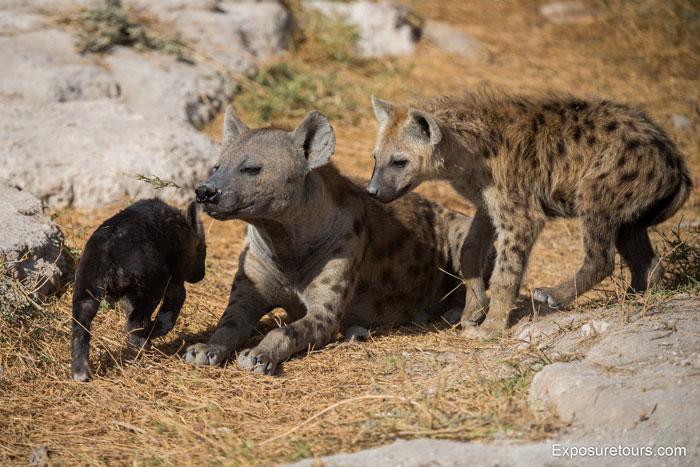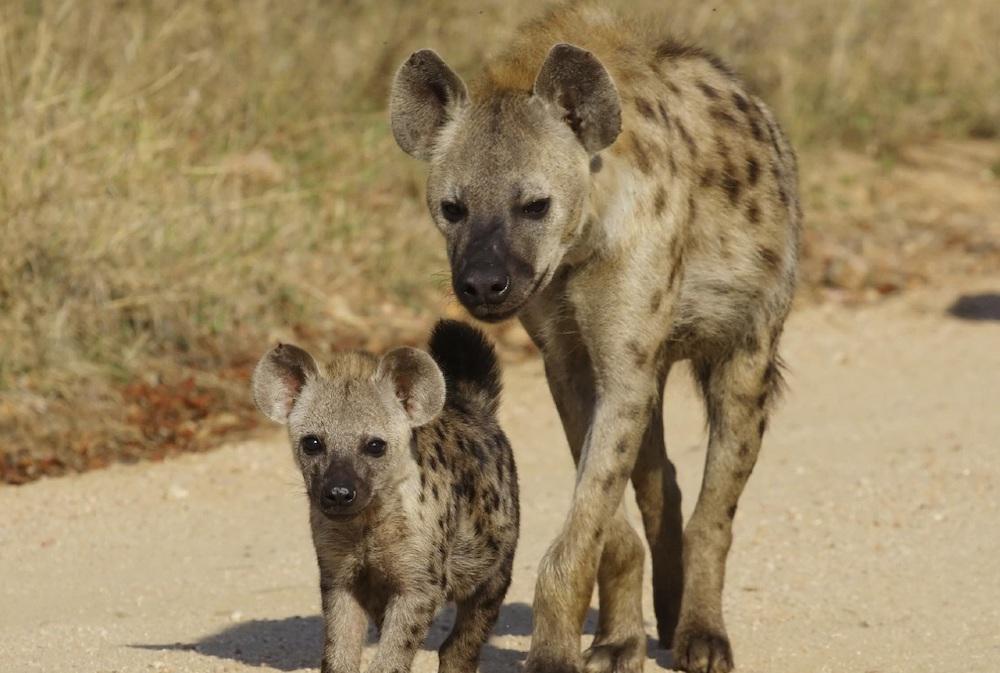The first image is the image on the left, the second image is the image on the right. Given the left and right images, does the statement "All of the images contain only one hyena." hold true? Answer yes or no. No. 